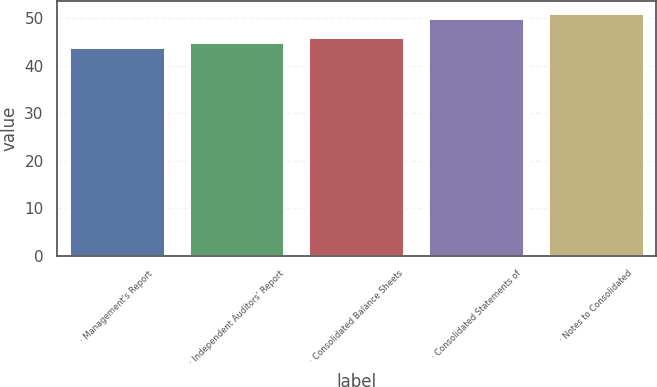<chart> <loc_0><loc_0><loc_500><loc_500><bar_chart><fcel>· Management's Report<fcel>· Independent Auditors' Report<fcel>· Consolidated Balance Sheets<fcel>· Consolidated Statements of<fcel>· Notes to Consolidated<nl><fcel>44<fcel>45<fcel>46<fcel>50<fcel>51<nl></chart> 